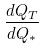<formula> <loc_0><loc_0><loc_500><loc_500>\frac { d Q _ { T } } { d Q _ { * } }</formula> 